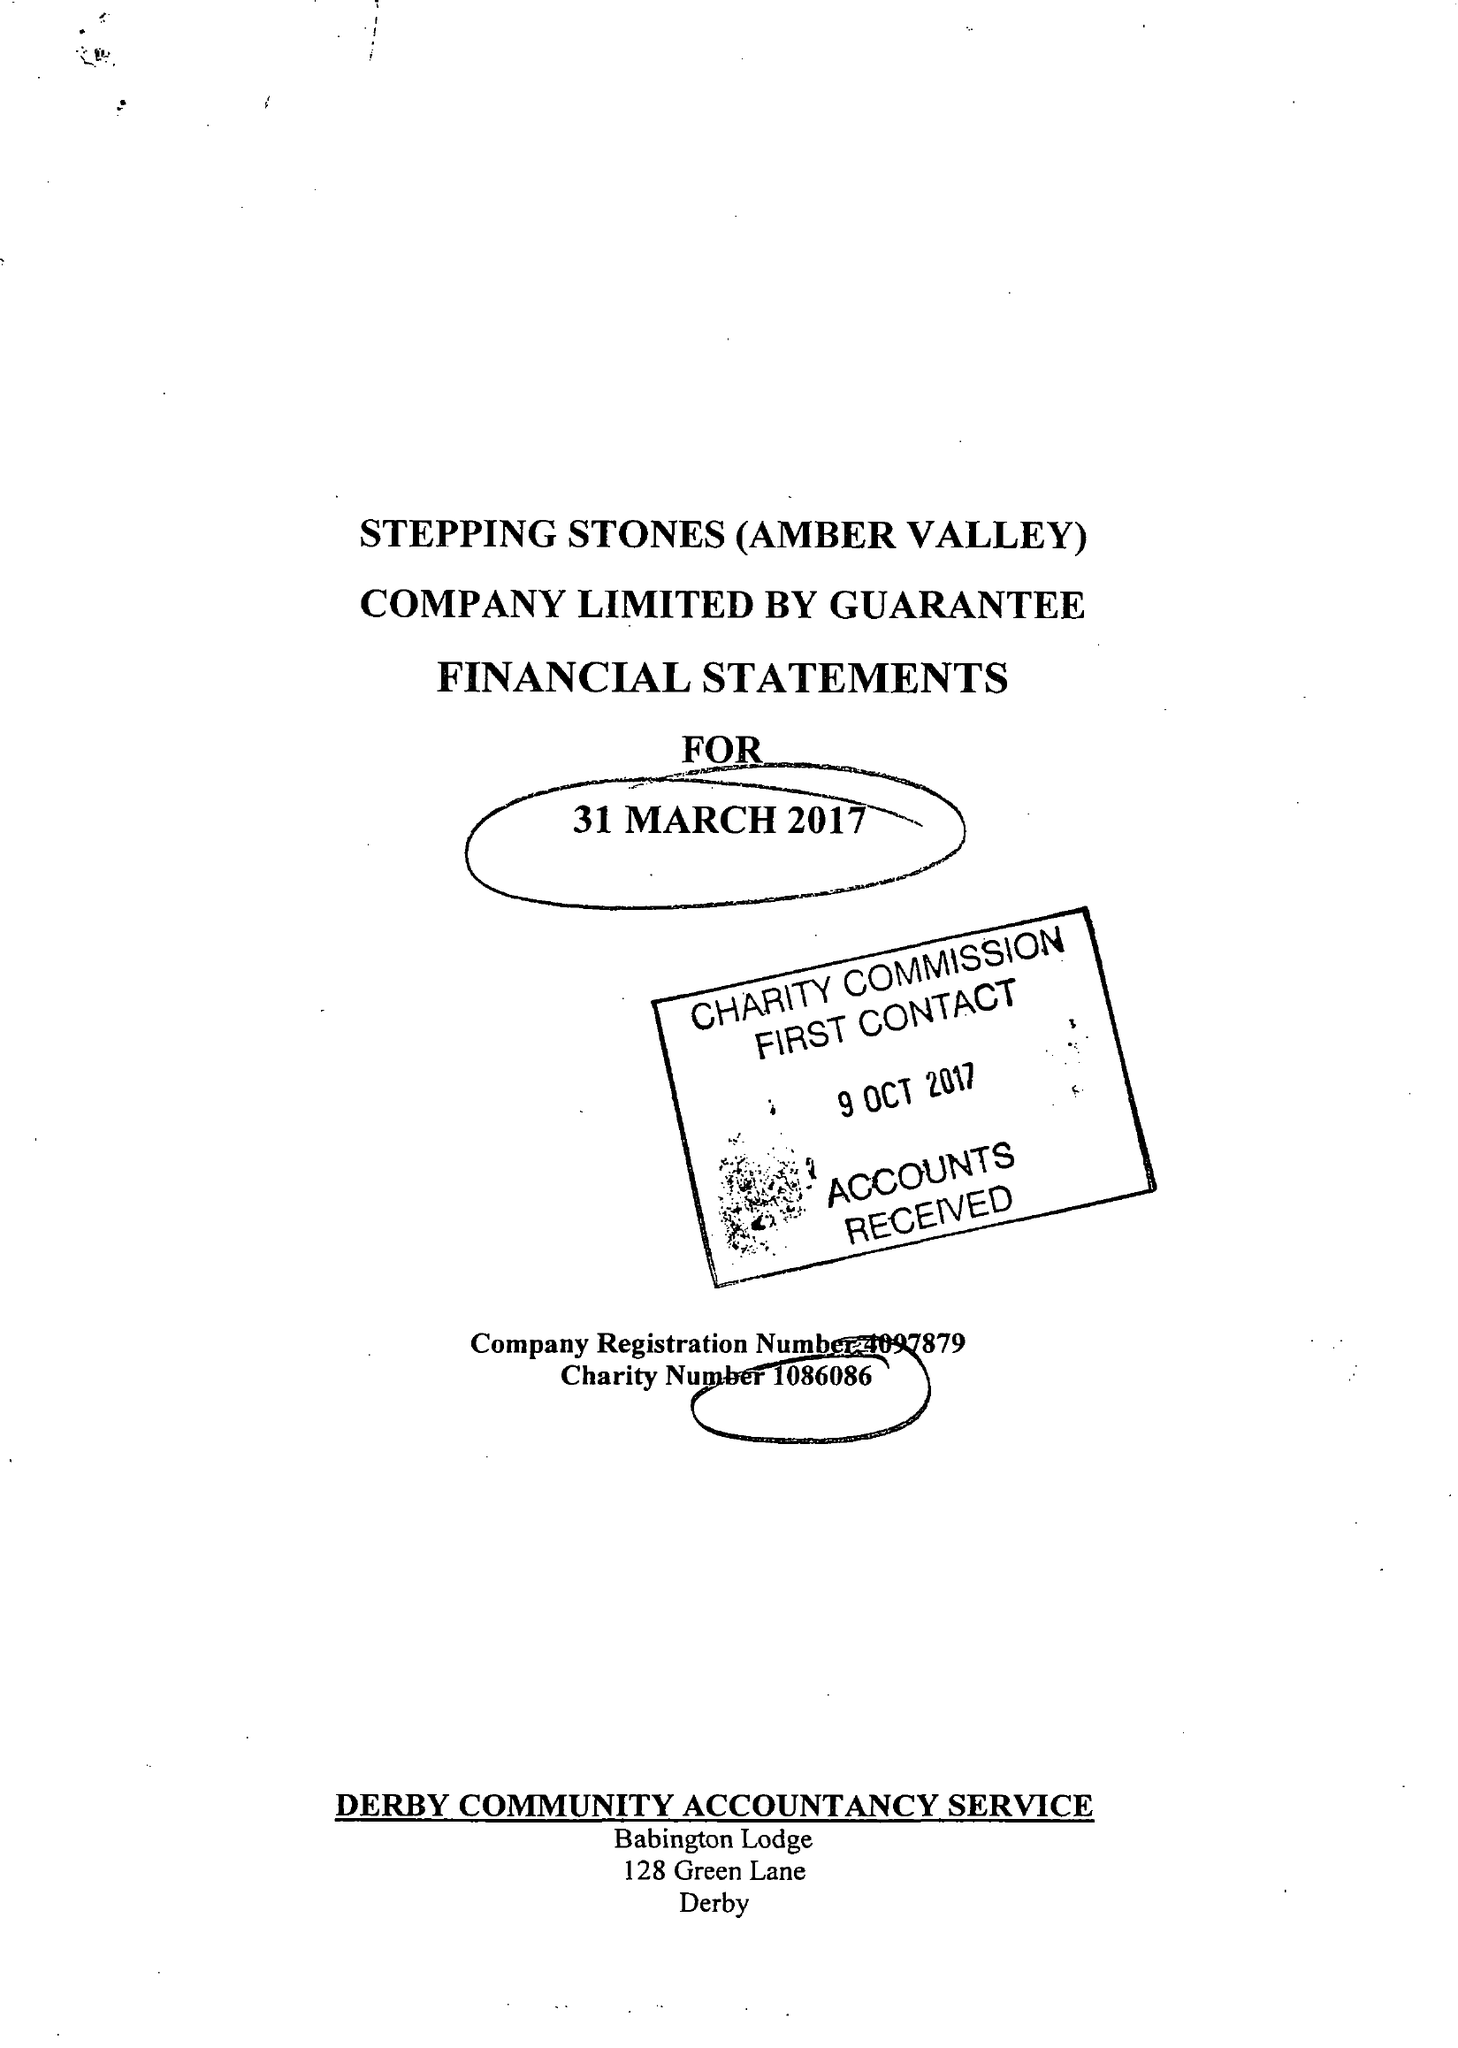What is the value for the charity_name?
Answer the question using a single word or phrase. Stepping Stones (Amber Valley) 